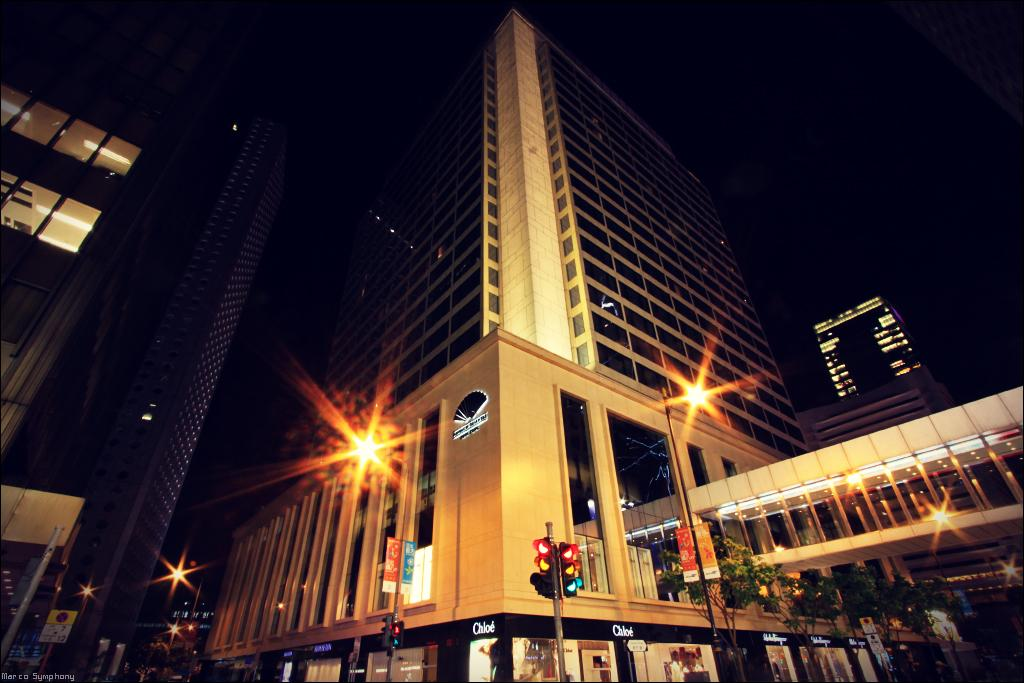What type of structures can be seen in the image? There are buildings in the image. What objects are present alongside the buildings? There are poles, lights, and traffic lights in the image. What type of vegetation is on the right side of the image? There are trees on the right side of the image. What is visible in the background of the image? The sky is visible in the background of the image. Can you tell me how many ears are visible on the buildings in the image? There are no ears present on the buildings in the image. What type of wind instrument is being played in the image? There is no wind instrument being played in the image. 